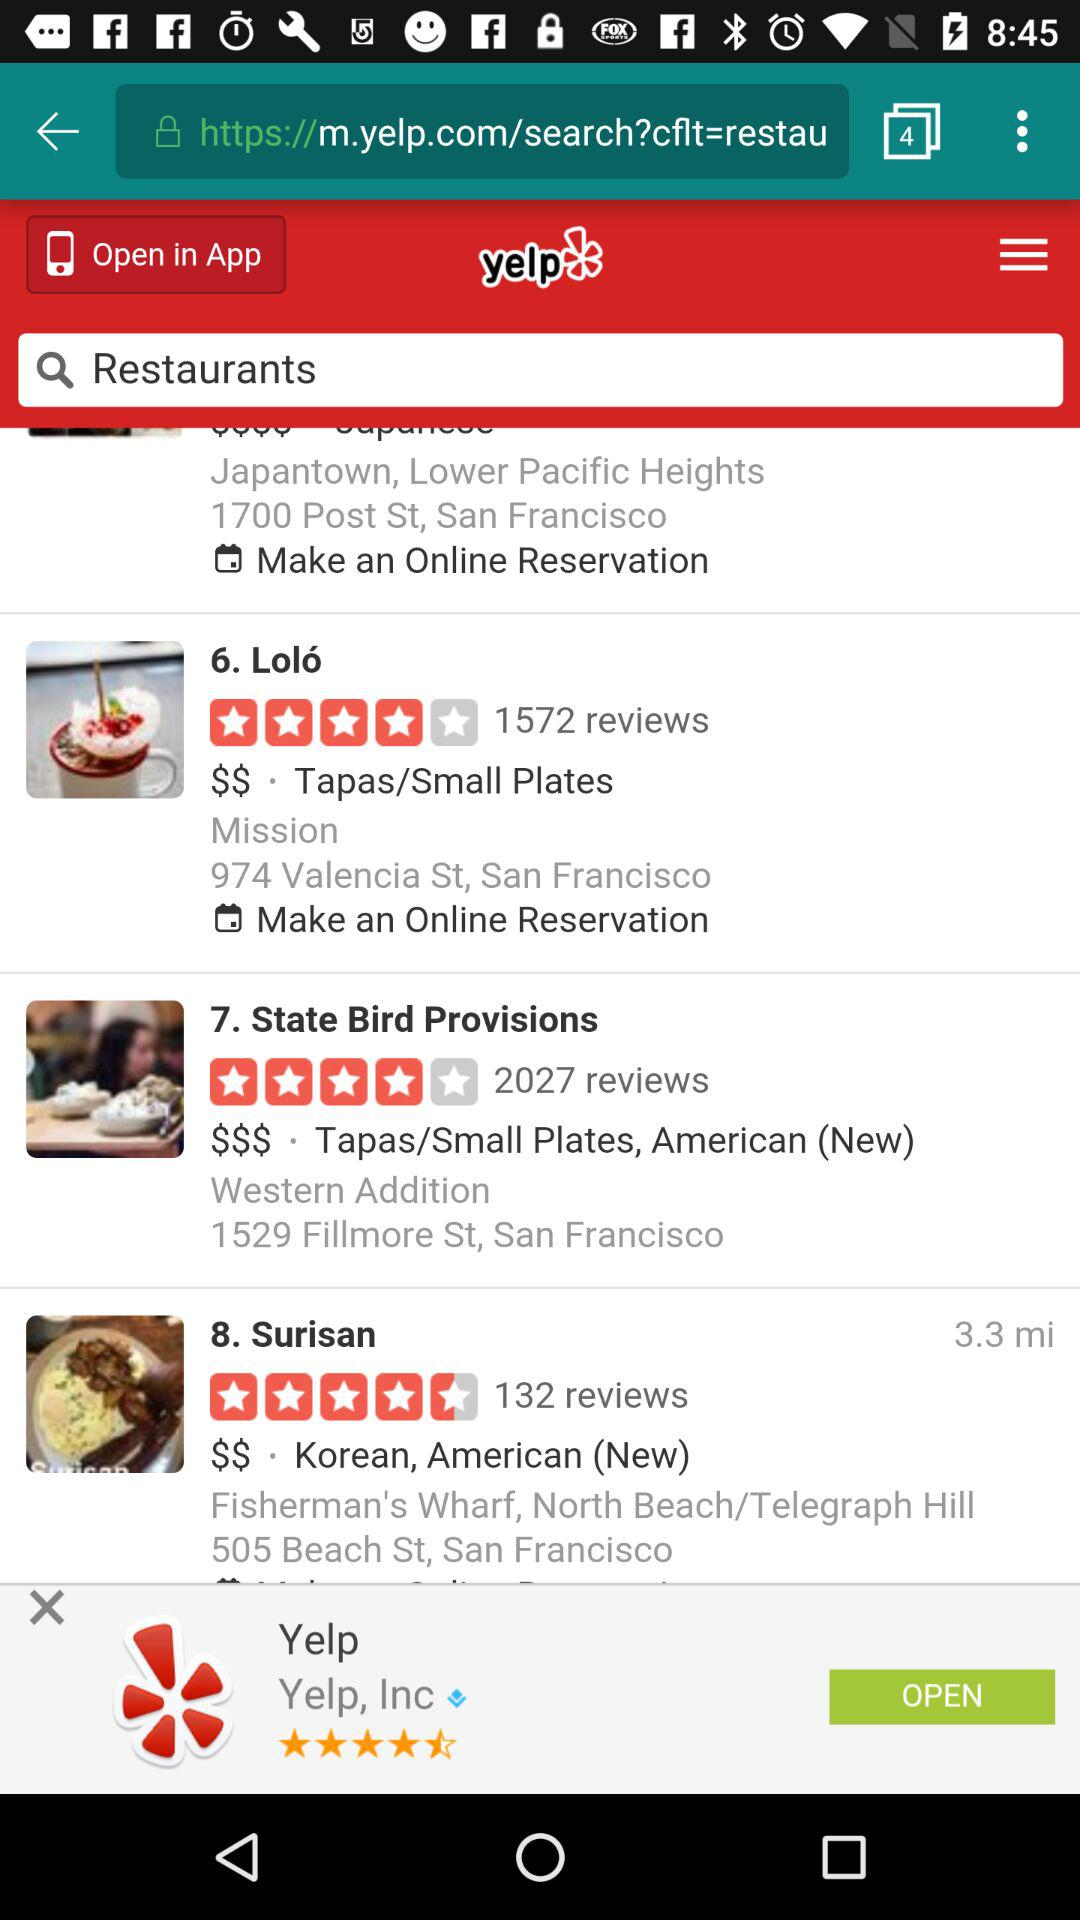What is the application name? The application name is "Yelp". 